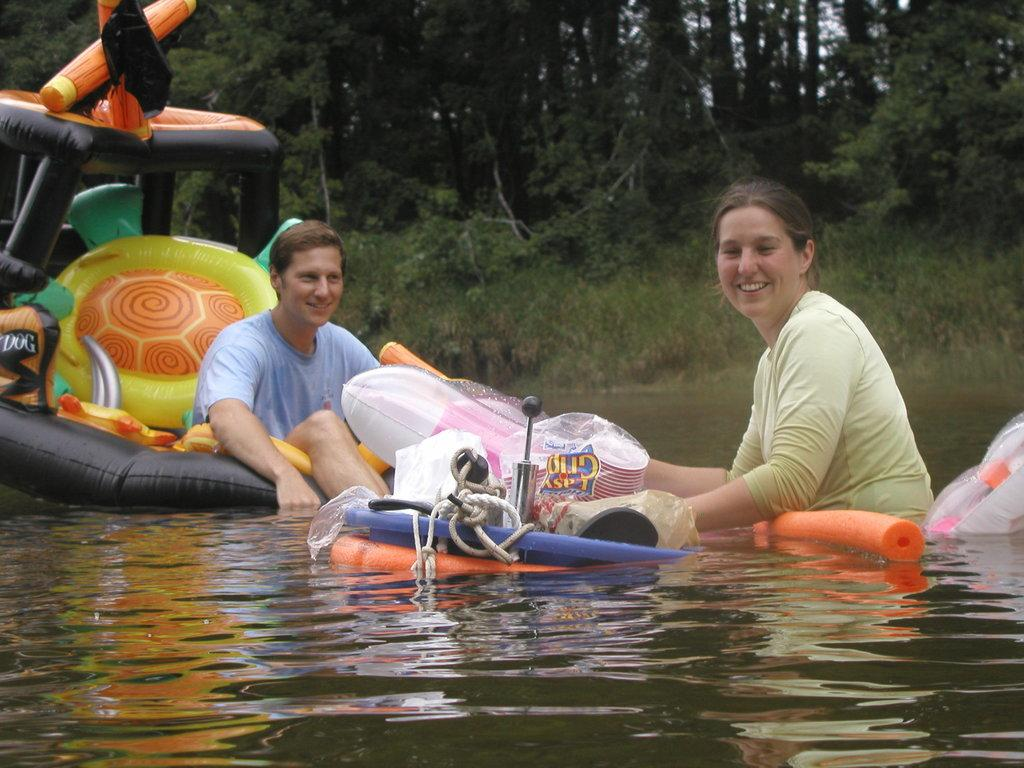What type of vehicle is in the image? There is an inflatable boat in the image. Where is the boat located? The boat is on water. Who is present in the image? There is a man and a woman in the image. What are the expressions of the man and woman? The man and woman are smiling. What can be seen in the background of the image? There are trees in the background of the image. What type of drug is the queen using in the image? There is no queen or drug present in the image. How many wheels are visible on the boat in the image? Inflatable boats do not have wheels, so none are visible in the image. 